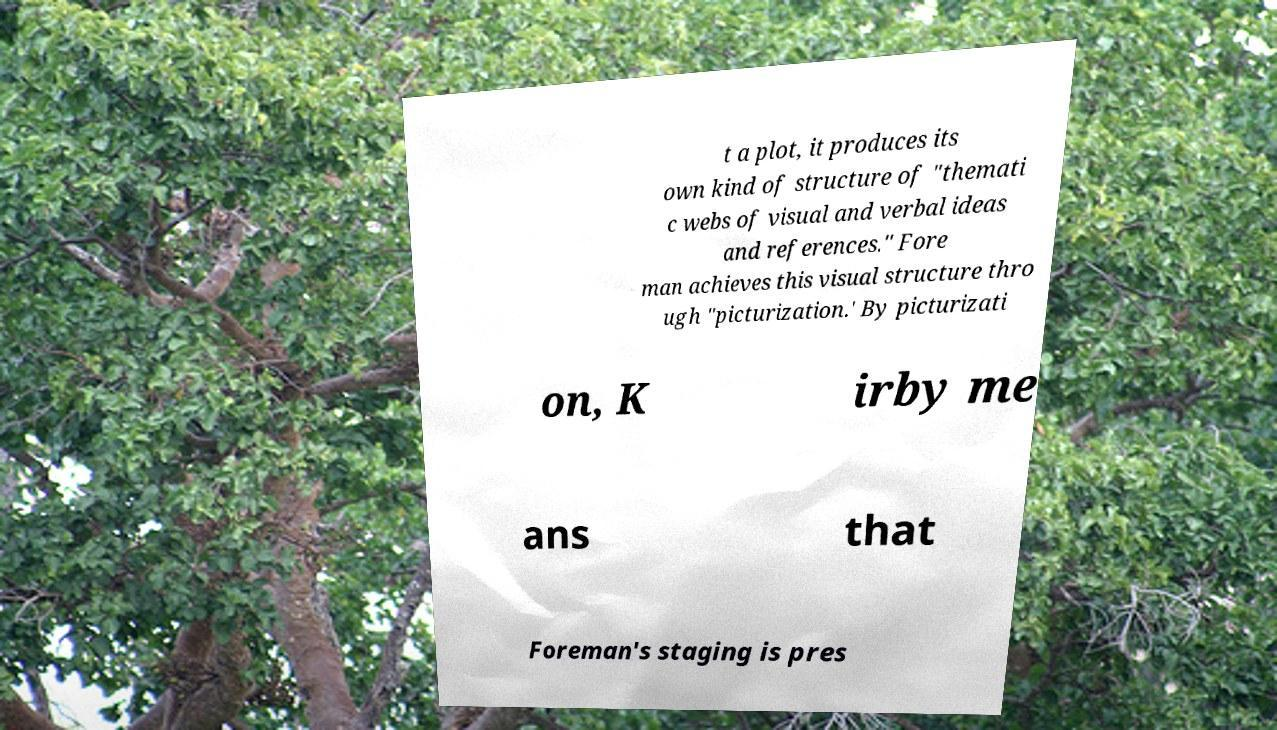There's text embedded in this image that I need extracted. Can you transcribe it verbatim? t a plot, it produces its own kind of structure of "themati c webs of visual and verbal ideas and references." Fore man achieves this visual structure thro ugh "picturization.' By picturizati on, K irby me ans that Foreman's staging is pres 